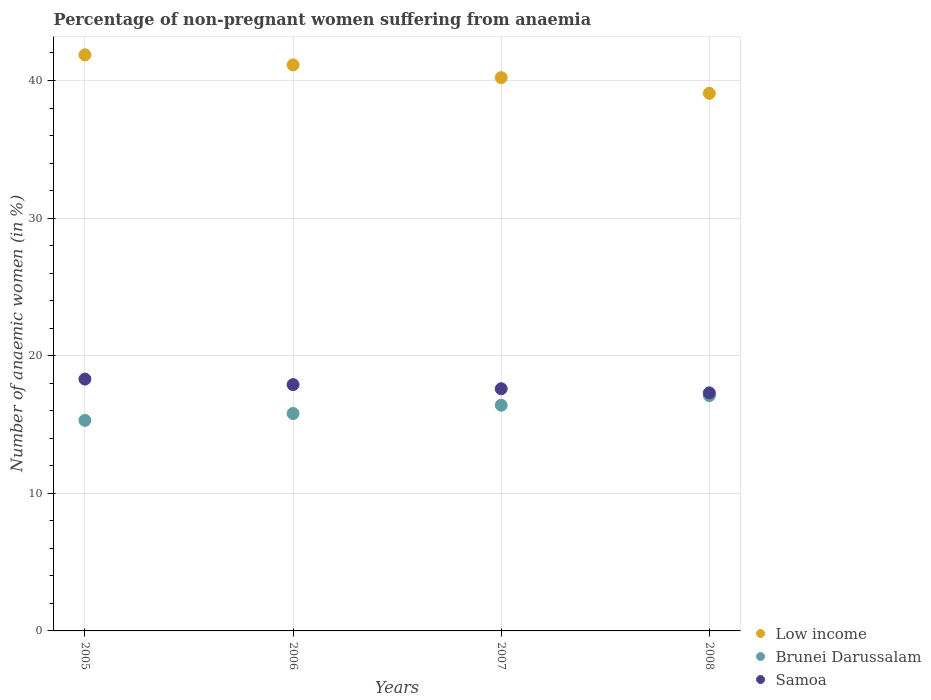How many different coloured dotlines are there?
Provide a short and direct response. 3. What is the percentage of non-pregnant women suffering from anaemia in Brunei Darussalam in 2005?
Keep it short and to the point. 15.3. Across all years, what is the maximum percentage of non-pregnant women suffering from anaemia in Low income?
Your answer should be compact. 41.86. Across all years, what is the minimum percentage of non-pregnant women suffering from anaemia in Samoa?
Provide a succinct answer. 17.3. What is the total percentage of non-pregnant women suffering from anaemia in Brunei Darussalam in the graph?
Your answer should be compact. 64.6. What is the difference between the percentage of non-pregnant women suffering from anaemia in Brunei Darussalam in 2005 and that in 2008?
Make the answer very short. -1.8. What is the difference between the percentage of non-pregnant women suffering from anaemia in Low income in 2006 and the percentage of non-pregnant women suffering from anaemia in Brunei Darussalam in 2005?
Your answer should be very brief. 25.83. What is the average percentage of non-pregnant women suffering from anaemia in Brunei Darussalam per year?
Ensure brevity in your answer.  16.15. In the year 2007, what is the difference between the percentage of non-pregnant women suffering from anaemia in Low income and percentage of non-pregnant women suffering from anaemia in Samoa?
Offer a terse response. 22.61. In how many years, is the percentage of non-pregnant women suffering from anaemia in Samoa greater than 34 %?
Offer a very short reply. 0. What is the ratio of the percentage of non-pregnant women suffering from anaemia in Brunei Darussalam in 2005 to that in 2007?
Make the answer very short. 0.93. Is the difference between the percentage of non-pregnant women suffering from anaemia in Low income in 2006 and 2007 greater than the difference between the percentage of non-pregnant women suffering from anaemia in Samoa in 2006 and 2007?
Give a very brief answer. Yes. What is the difference between the highest and the second highest percentage of non-pregnant women suffering from anaemia in Brunei Darussalam?
Your answer should be compact. 0.7. What is the difference between the highest and the lowest percentage of non-pregnant women suffering from anaemia in Brunei Darussalam?
Your response must be concise. 1.8. Is the sum of the percentage of non-pregnant women suffering from anaemia in Low income in 2007 and 2008 greater than the maximum percentage of non-pregnant women suffering from anaemia in Brunei Darussalam across all years?
Provide a succinct answer. Yes. Does the percentage of non-pregnant women suffering from anaemia in Brunei Darussalam monotonically increase over the years?
Offer a very short reply. Yes. Is the percentage of non-pregnant women suffering from anaemia in Brunei Darussalam strictly less than the percentage of non-pregnant women suffering from anaemia in Low income over the years?
Your response must be concise. Yes. How many dotlines are there?
Provide a succinct answer. 3. How many years are there in the graph?
Provide a succinct answer. 4. Are the values on the major ticks of Y-axis written in scientific E-notation?
Provide a short and direct response. No. Does the graph contain any zero values?
Provide a short and direct response. No. Does the graph contain grids?
Make the answer very short. Yes. How many legend labels are there?
Give a very brief answer. 3. How are the legend labels stacked?
Offer a very short reply. Vertical. What is the title of the graph?
Your answer should be very brief. Percentage of non-pregnant women suffering from anaemia. Does "Congo (Republic)" appear as one of the legend labels in the graph?
Your answer should be compact. No. What is the label or title of the Y-axis?
Your answer should be compact. Number of anaemic women (in %). What is the Number of anaemic women (in %) in Low income in 2005?
Make the answer very short. 41.86. What is the Number of anaemic women (in %) in Low income in 2006?
Give a very brief answer. 41.13. What is the Number of anaemic women (in %) in Low income in 2007?
Your answer should be compact. 40.21. What is the Number of anaemic women (in %) of Brunei Darussalam in 2007?
Offer a terse response. 16.4. What is the Number of anaemic women (in %) in Low income in 2008?
Give a very brief answer. 39.06. What is the Number of anaemic women (in %) of Brunei Darussalam in 2008?
Provide a succinct answer. 17.1. Across all years, what is the maximum Number of anaemic women (in %) of Low income?
Keep it short and to the point. 41.86. Across all years, what is the maximum Number of anaemic women (in %) of Samoa?
Offer a very short reply. 18.3. Across all years, what is the minimum Number of anaemic women (in %) in Low income?
Your answer should be very brief. 39.06. Across all years, what is the minimum Number of anaemic women (in %) of Brunei Darussalam?
Offer a very short reply. 15.3. What is the total Number of anaemic women (in %) of Low income in the graph?
Make the answer very short. 162.27. What is the total Number of anaemic women (in %) in Brunei Darussalam in the graph?
Keep it short and to the point. 64.6. What is the total Number of anaemic women (in %) in Samoa in the graph?
Offer a terse response. 71.1. What is the difference between the Number of anaemic women (in %) of Low income in 2005 and that in 2006?
Ensure brevity in your answer.  0.73. What is the difference between the Number of anaemic women (in %) in Brunei Darussalam in 2005 and that in 2006?
Your answer should be compact. -0.5. What is the difference between the Number of anaemic women (in %) of Low income in 2005 and that in 2007?
Ensure brevity in your answer.  1.65. What is the difference between the Number of anaemic women (in %) in Samoa in 2005 and that in 2007?
Offer a very short reply. 0.7. What is the difference between the Number of anaemic women (in %) in Low income in 2005 and that in 2008?
Provide a short and direct response. 2.8. What is the difference between the Number of anaemic women (in %) in Brunei Darussalam in 2005 and that in 2008?
Offer a terse response. -1.8. What is the difference between the Number of anaemic women (in %) in Low income in 2006 and that in 2007?
Provide a short and direct response. 0.93. What is the difference between the Number of anaemic women (in %) of Samoa in 2006 and that in 2007?
Offer a very short reply. 0.3. What is the difference between the Number of anaemic women (in %) in Low income in 2006 and that in 2008?
Ensure brevity in your answer.  2.07. What is the difference between the Number of anaemic women (in %) of Low income in 2007 and that in 2008?
Provide a succinct answer. 1.14. What is the difference between the Number of anaemic women (in %) of Brunei Darussalam in 2007 and that in 2008?
Your answer should be very brief. -0.7. What is the difference between the Number of anaemic women (in %) of Samoa in 2007 and that in 2008?
Offer a terse response. 0.3. What is the difference between the Number of anaemic women (in %) in Low income in 2005 and the Number of anaemic women (in %) in Brunei Darussalam in 2006?
Ensure brevity in your answer.  26.06. What is the difference between the Number of anaemic women (in %) in Low income in 2005 and the Number of anaemic women (in %) in Samoa in 2006?
Provide a short and direct response. 23.96. What is the difference between the Number of anaemic women (in %) in Brunei Darussalam in 2005 and the Number of anaemic women (in %) in Samoa in 2006?
Give a very brief answer. -2.6. What is the difference between the Number of anaemic women (in %) of Low income in 2005 and the Number of anaemic women (in %) of Brunei Darussalam in 2007?
Your answer should be compact. 25.46. What is the difference between the Number of anaemic women (in %) of Low income in 2005 and the Number of anaemic women (in %) of Samoa in 2007?
Provide a succinct answer. 24.26. What is the difference between the Number of anaemic women (in %) in Brunei Darussalam in 2005 and the Number of anaemic women (in %) in Samoa in 2007?
Your response must be concise. -2.3. What is the difference between the Number of anaemic women (in %) of Low income in 2005 and the Number of anaemic women (in %) of Brunei Darussalam in 2008?
Make the answer very short. 24.76. What is the difference between the Number of anaemic women (in %) of Low income in 2005 and the Number of anaemic women (in %) of Samoa in 2008?
Provide a short and direct response. 24.56. What is the difference between the Number of anaemic women (in %) in Low income in 2006 and the Number of anaemic women (in %) in Brunei Darussalam in 2007?
Provide a short and direct response. 24.73. What is the difference between the Number of anaemic women (in %) in Low income in 2006 and the Number of anaemic women (in %) in Samoa in 2007?
Keep it short and to the point. 23.53. What is the difference between the Number of anaemic women (in %) in Brunei Darussalam in 2006 and the Number of anaemic women (in %) in Samoa in 2007?
Give a very brief answer. -1.8. What is the difference between the Number of anaemic women (in %) in Low income in 2006 and the Number of anaemic women (in %) in Brunei Darussalam in 2008?
Ensure brevity in your answer.  24.03. What is the difference between the Number of anaemic women (in %) of Low income in 2006 and the Number of anaemic women (in %) of Samoa in 2008?
Give a very brief answer. 23.83. What is the difference between the Number of anaemic women (in %) of Low income in 2007 and the Number of anaemic women (in %) of Brunei Darussalam in 2008?
Ensure brevity in your answer.  23.11. What is the difference between the Number of anaemic women (in %) of Low income in 2007 and the Number of anaemic women (in %) of Samoa in 2008?
Offer a very short reply. 22.91. What is the difference between the Number of anaemic women (in %) in Brunei Darussalam in 2007 and the Number of anaemic women (in %) in Samoa in 2008?
Your response must be concise. -0.9. What is the average Number of anaemic women (in %) of Low income per year?
Ensure brevity in your answer.  40.57. What is the average Number of anaemic women (in %) of Brunei Darussalam per year?
Keep it short and to the point. 16.15. What is the average Number of anaemic women (in %) of Samoa per year?
Provide a short and direct response. 17.77. In the year 2005, what is the difference between the Number of anaemic women (in %) of Low income and Number of anaemic women (in %) of Brunei Darussalam?
Your answer should be compact. 26.56. In the year 2005, what is the difference between the Number of anaemic women (in %) in Low income and Number of anaemic women (in %) in Samoa?
Provide a succinct answer. 23.56. In the year 2005, what is the difference between the Number of anaemic women (in %) in Brunei Darussalam and Number of anaemic women (in %) in Samoa?
Your answer should be compact. -3. In the year 2006, what is the difference between the Number of anaemic women (in %) of Low income and Number of anaemic women (in %) of Brunei Darussalam?
Offer a terse response. 25.33. In the year 2006, what is the difference between the Number of anaemic women (in %) of Low income and Number of anaemic women (in %) of Samoa?
Ensure brevity in your answer.  23.23. In the year 2006, what is the difference between the Number of anaemic women (in %) in Brunei Darussalam and Number of anaemic women (in %) in Samoa?
Your response must be concise. -2.1. In the year 2007, what is the difference between the Number of anaemic women (in %) in Low income and Number of anaemic women (in %) in Brunei Darussalam?
Offer a very short reply. 23.81. In the year 2007, what is the difference between the Number of anaemic women (in %) in Low income and Number of anaemic women (in %) in Samoa?
Your answer should be very brief. 22.61. In the year 2008, what is the difference between the Number of anaemic women (in %) in Low income and Number of anaemic women (in %) in Brunei Darussalam?
Give a very brief answer. 21.96. In the year 2008, what is the difference between the Number of anaemic women (in %) in Low income and Number of anaemic women (in %) in Samoa?
Give a very brief answer. 21.76. In the year 2008, what is the difference between the Number of anaemic women (in %) of Brunei Darussalam and Number of anaemic women (in %) of Samoa?
Your response must be concise. -0.2. What is the ratio of the Number of anaemic women (in %) in Low income in 2005 to that in 2006?
Give a very brief answer. 1.02. What is the ratio of the Number of anaemic women (in %) in Brunei Darussalam in 2005 to that in 2006?
Provide a short and direct response. 0.97. What is the ratio of the Number of anaemic women (in %) of Samoa in 2005 to that in 2006?
Ensure brevity in your answer.  1.02. What is the ratio of the Number of anaemic women (in %) of Low income in 2005 to that in 2007?
Make the answer very short. 1.04. What is the ratio of the Number of anaemic women (in %) of Brunei Darussalam in 2005 to that in 2007?
Make the answer very short. 0.93. What is the ratio of the Number of anaemic women (in %) of Samoa in 2005 to that in 2007?
Your answer should be very brief. 1.04. What is the ratio of the Number of anaemic women (in %) in Low income in 2005 to that in 2008?
Offer a terse response. 1.07. What is the ratio of the Number of anaemic women (in %) in Brunei Darussalam in 2005 to that in 2008?
Your answer should be compact. 0.89. What is the ratio of the Number of anaemic women (in %) of Samoa in 2005 to that in 2008?
Offer a terse response. 1.06. What is the ratio of the Number of anaemic women (in %) in Low income in 2006 to that in 2007?
Your answer should be compact. 1.02. What is the ratio of the Number of anaemic women (in %) in Brunei Darussalam in 2006 to that in 2007?
Your response must be concise. 0.96. What is the ratio of the Number of anaemic women (in %) of Samoa in 2006 to that in 2007?
Ensure brevity in your answer.  1.02. What is the ratio of the Number of anaemic women (in %) of Low income in 2006 to that in 2008?
Offer a terse response. 1.05. What is the ratio of the Number of anaemic women (in %) of Brunei Darussalam in 2006 to that in 2008?
Your response must be concise. 0.92. What is the ratio of the Number of anaemic women (in %) in Samoa in 2006 to that in 2008?
Keep it short and to the point. 1.03. What is the ratio of the Number of anaemic women (in %) in Low income in 2007 to that in 2008?
Your response must be concise. 1.03. What is the ratio of the Number of anaemic women (in %) of Brunei Darussalam in 2007 to that in 2008?
Your answer should be compact. 0.96. What is the ratio of the Number of anaemic women (in %) of Samoa in 2007 to that in 2008?
Offer a terse response. 1.02. What is the difference between the highest and the second highest Number of anaemic women (in %) in Low income?
Your answer should be compact. 0.73. What is the difference between the highest and the second highest Number of anaemic women (in %) in Brunei Darussalam?
Your answer should be compact. 0.7. What is the difference between the highest and the lowest Number of anaemic women (in %) in Low income?
Offer a very short reply. 2.8. What is the difference between the highest and the lowest Number of anaemic women (in %) of Samoa?
Provide a short and direct response. 1. 